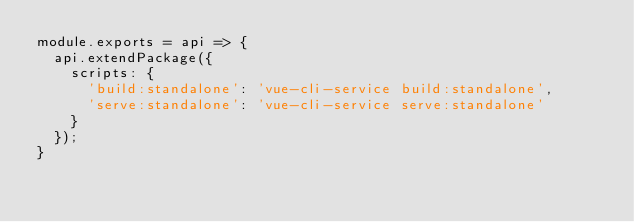Convert code to text. <code><loc_0><loc_0><loc_500><loc_500><_JavaScript_>module.exports = api => {
  api.extendPackage({
    scripts: {
      'build:standalone': 'vue-cli-service build:standalone',
      'serve:standalone': 'vue-cli-service serve:standalone'
    }
  });
}</code> 